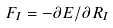Convert formula to latex. <formula><loc_0><loc_0><loc_500><loc_500>F _ { I } = - \partial E / \partial R _ { I }</formula> 